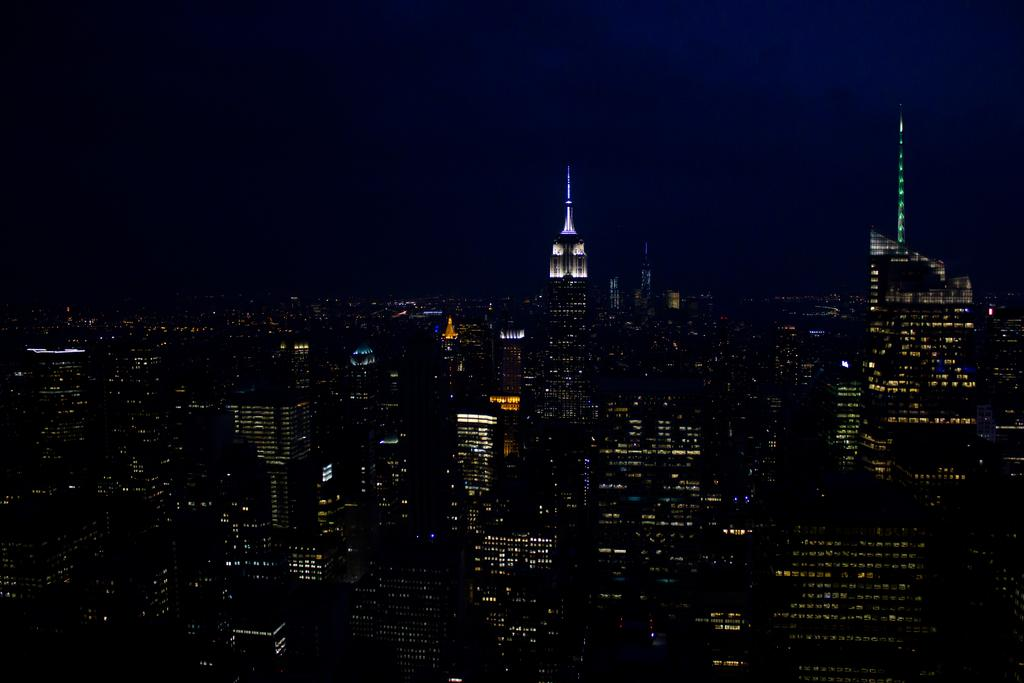What is the overall tone or appearance of the image? The image is dark. What type of structures can be seen in the image? There are buildings in the image. Are there any sources of illumination in the image? Yes, there are lights in the image. What part of the natural environment is visible in the image? The sky is visible in the image. What type of marble is used to construct the buildings in the image? There is no mention of marble being used in the construction of the buildings in the image. Can you hear the zephyr blowing through the buildings in the image? The image is a still picture and does not convey sound, so it is impossible to hear the zephyr or any other sounds. 